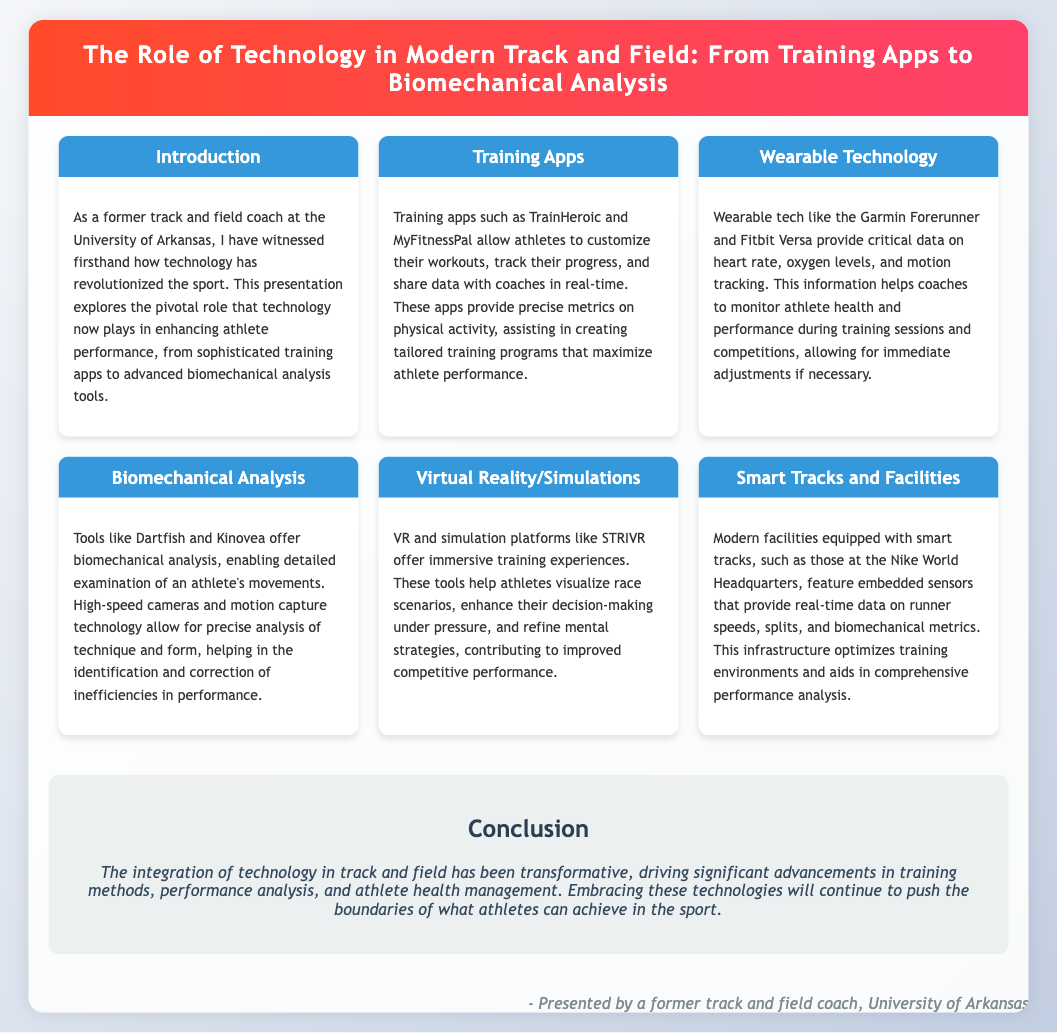What are some examples of training apps? The document lists specific training apps that enhance athlete performance, including TrainHeroic and MyFitnessPal.
Answer: TrainHeroic, MyFitnessPal What do wearable technologies monitor? The section on wearable technology mentions that these devices track heart rate, oxygen levels, and motion.
Answer: Heart rate, oxygen levels, motion Which tool is used for biomechanical analysis? The document cites Dartfish and Kinovea as tools for detailed examination of athlete movements and technique.
Answer: Dartfish, Kinovea What does STRIVR offer? The document describes STRIVR as a platform that provides immersive training experiences and helps athletes refine strategies.
Answer: Immersive training experiences What is the main conclusion of the presentation? The conclusion summarizes the transformative impact of technology on training methods and athlete management in track and field.
Answer: Transformative impact How do smart tracks assist coaches? The document explains that smart tracks provide real-time data on runners, aiding in performance monitoring and analysis.
Answer: Real-time data What is the focus of the introduction section? The introduction emphasizes the revolutionary role of technology in enhancing athlete performance and outlines the presentation's contents.
Answer: Revolutionary role of technology How do training apps assist in creating programs? The document mentions that training apps provide precise metrics on physical activity, which helps in creating tailored training programs.
Answer: Precise metrics on physical activity 